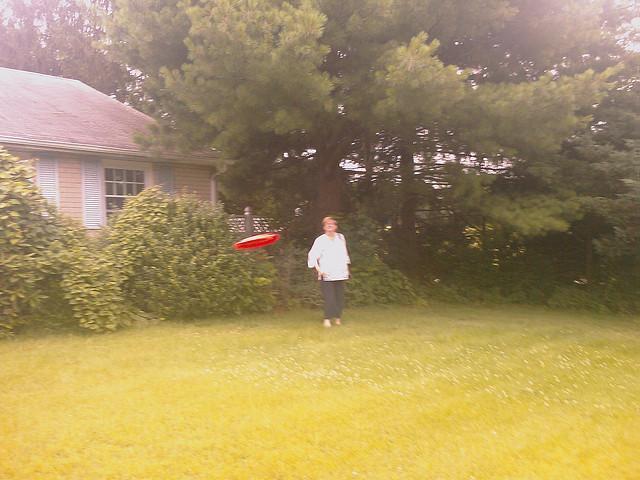How many already fried donuts are there in the image?
Give a very brief answer. 0. 